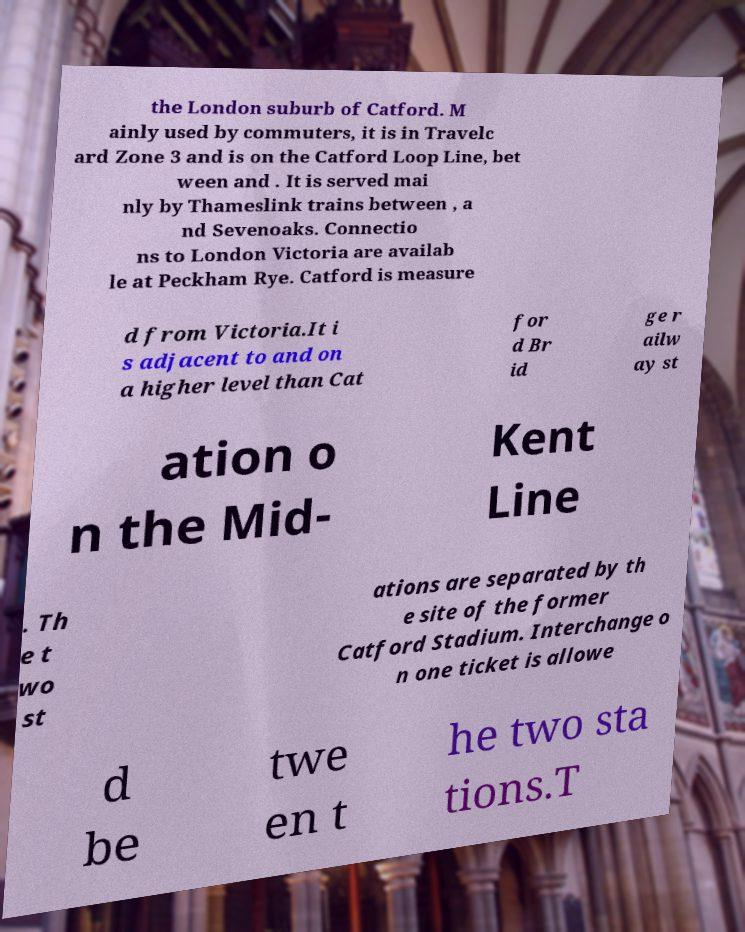Can you accurately transcribe the text from the provided image for me? the London suburb of Catford. M ainly used by commuters, it is in Travelc ard Zone 3 and is on the Catford Loop Line, bet ween and . It is served mai nly by Thameslink trains between , a nd Sevenoaks. Connectio ns to London Victoria are availab le at Peckham Rye. Catford is measure d from Victoria.It i s adjacent to and on a higher level than Cat for d Br id ge r ailw ay st ation o n the Mid- Kent Line . Th e t wo st ations are separated by th e site of the former Catford Stadium. Interchange o n one ticket is allowe d be twe en t he two sta tions.T 